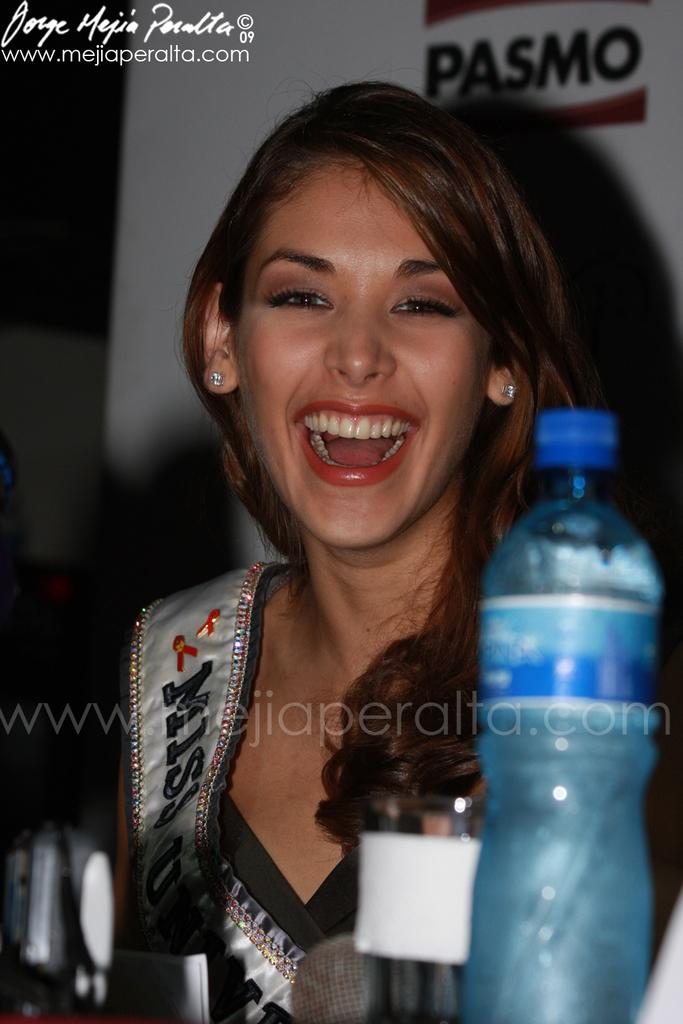Who is in the picture? There is a woman in the picture. What is the woman doing in the picture? The woman is smiling in the picture. What object can be seen in the foreground of the image? There is a water bottle in the foreground of the image. What is visible in the background of the image? There is a banner in the background of the image. What text is present in the image? There is text written in the top left corner of the image. What time of day is the scene taking place in the image? The provided facts do not mention the time of day, so it cannot be determined from the image. 